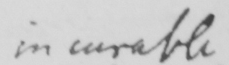Can you tell me what this handwritten text says? incurable 